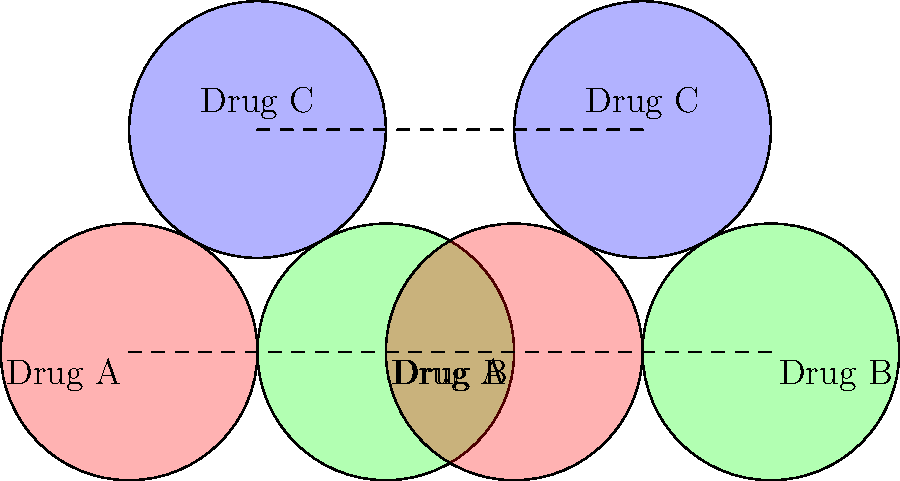As the CEO of a pharmaceutical company, you're analyzing a Venn diagram representing drug interaction probabilities for three drugs: A, B, and C. The diagram has been translated 3 units to the right. What is the vector that represents this translation, and how does this transformation affect the interpretation of drug interaction probabilities? To solve this problem, let's follow these steps:

1. Identify the translation:
   The Venn diagram has been moved 3 units to the right, which in vector notation is represented as $(3,0)$.

2. Effect on diagram:
   - The entire diagram, including all three circles representing drugs A, B, and C, has been shifted 3 units to the right.
   - The relative positions and overlaps of the circles remain unchanged.

3. Interpretation of drug interaction probabilities:
   - The translation does not change the size or overlap of the circles, which represent the interaction probabilities.
   - The areas of overlap between circles (representing drug interactions) remain the same.
   - The translation merely creates a copy of the original diagram, allowing for comparison or additional analysis.

4. Implications for decision-making:
   - The translated diagram provides no new information about drug interactions.
   - However, it could be useful for:
     a) Comparing two different sets of drugs with similar interaction patterns.
     b) Analyzing changes in interaction probabilities over time (if the translated diagram represents a different time point).
     c) Visualizing the effect of a specific variable on drug interactions (if the translation represents a change in that variable).

5. Vector representation:
   The translation vector $(3,0)$ indicates:
   - A movement of 3 units in the positive x-direction
   - No movement in the y-direction

In conclusion, while the translation vector is $(3,0)$, this transformation does not alter the drug interaction probabilities represented by the overlapping areas in the Venn diagram. The CEO should focus on the relative sizes and overlaps of the circles rather than their absolute positions when making decisions based on this data.
Answer: $(3,0)$; no effect on probabilities 